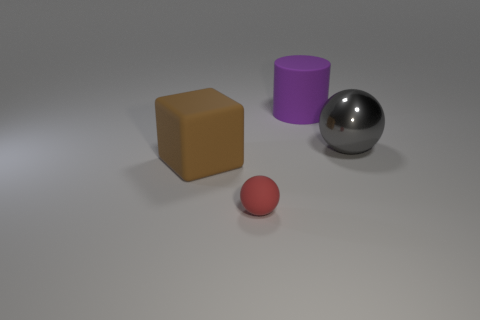Are there any other things that are the same material as the large gray object?
Provide a succinct answer. No. Is there any other thing that has the same size as the rubber sphere?
Your response must be concise. No. How many matte things are behind the tiny rubber thing and to the left of the rubber cylinder?
Offer a terse response. 1. Is the number of large cylinders in front of the small rubber thing less than the number of gray metallic things?
Ensure brevity in your answer.  Yes. What shape is the brown object that is the same size as the gray thing?
Your answer should be compact. Cube. How many other objects are the same color as the metallic sphere?
Your answer should be very brief. 0. Is the brown block the same size as the red object?
Provide a succinct answer. No. What number of things are either small gray matte objects or objects that are right of the large brown rubber object?
Give a very brief answer. 3. Are there fewer large purple matte cylinders on the right side of the large matte cylinder than red matte things to the left of the shiny thing?
Offer a terse response. Yes. How many other objects are the same material as the big gray object?
Provide a succinct answer. 0. 